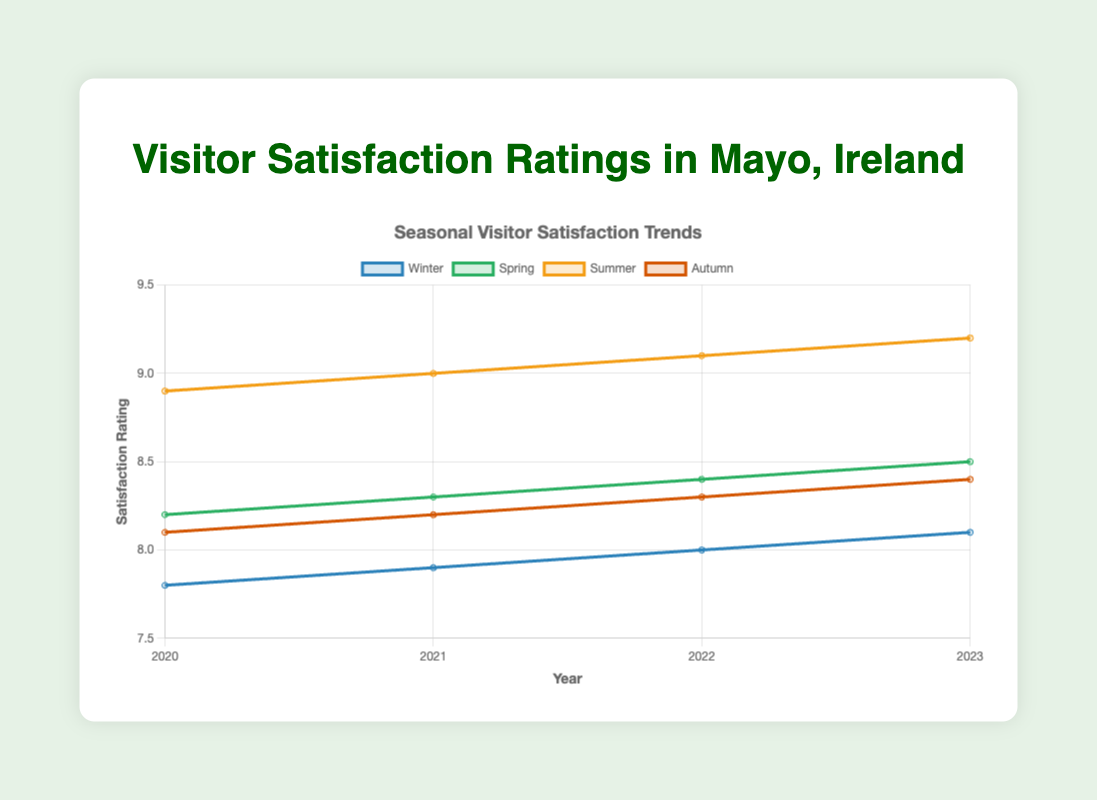what is the average visitor satisfaction rating for Summer from 2020 to 2023? The ratings for Summer from 2020 to 2023 are 8.9, 9.0, 9.1, and 9.2. Summing these values gives 35.2, and dividing by 4 gives an average rating. 35.2 / 4 = 8.8
Answer: 8.8 In which season did the visitor satisfaction rating consistently increase from 2020 to 2023? The satisfaction ratings for each season need to be checked for an increasing trend. Winter: 7.8, 7.9, 8.0, 8.1; Spring: 8.2, 8.3, 8.4, 8.5; Summer: 8.9, 9.0, 9.1, 9.2; Autumn: 8.1, 8.2, 8.3, 8.4. All seasons show consistent increases.
Answer: Winter, Spring, Summer, Autumn What is the difference between the highest and lowest satisfaction ratings in 2021? The highest rating in 2021 is for Summer (9.0) and the lowest is for Winter (7.9). The difference is calculated as 9.0 - 7.9.
Answer: 1.1 Which season had the least improvement in visitor satisfaction from 2020 to 2023? The improvement for each season is calculated as the difference between the 2023 and 2020 ratings. Winter: 8.1 - 7.8 = 0.3, Spring: 8.5 - 8.2 = 0.3, Summer: 9.2 - 8.9 = 0.3, Autumn: 8.4 - 8.1 = 0.3. All seasons had the same level of improvement.
Answer: All seasons are the same During which year did Spring have the highest satisfaction rating? Review the ratings for Spring: 2020 - 8.2, 2021 - 8.3, 2022 - 8.4, 2023 - 8.5. The highest rating is in 2023.
Answer: 2023 Compare the visitor satisfaction ratings of Winter and Autumn in 2023. Which is higher? The rating for Winter 2023 is 8.1, and for Autumn 2023, it is 8.4. Autumn has a higher rating.
Answer: Autumn What is the trend of the Summer satisfaction rating curve from 2020 to 2023? Observing the Summer satisfaction ratings: 2020 - 8.9, 2021 - 9.0, 2022 - 9.1, 2023 - 9.2, there is a consistently increasing trend.
Answer: Increasing 